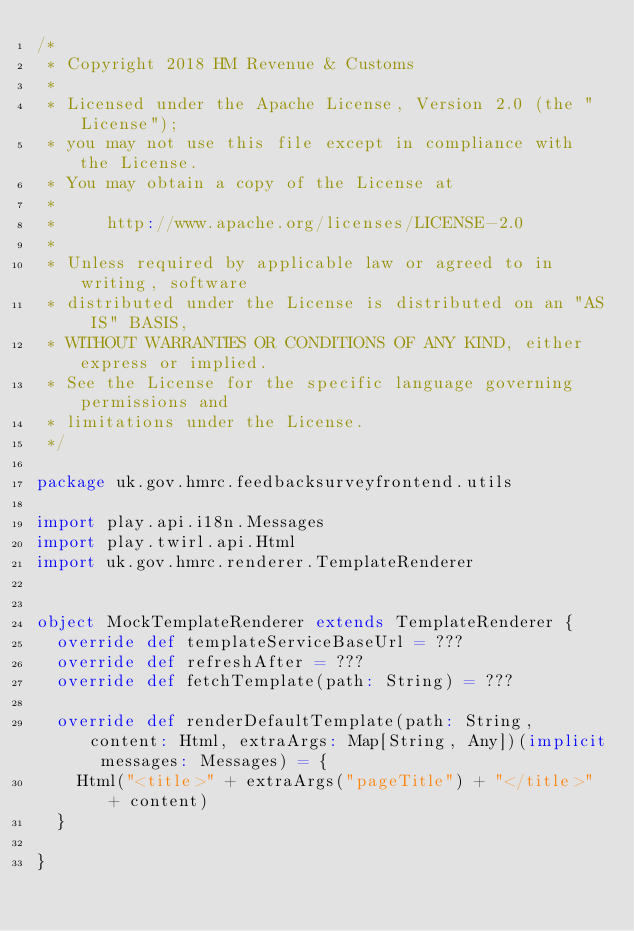<code> <loc_0><loc_0><loc_500><loc_500><_Scala_>/*
 * Copyright 2018 HM Revenue & Customs
 *
 * Licensed under the Apache License, Version 2.0 (the "License");
 * you may not use this file except in compliance with the License.
 * You may obtain a copy of the License at
 *
 *     http://www.apache.org/licenses/LICENSE-2.0
 *
 * Unless required by applicable law or agreed to in writing, software
 * distributed under the License is distributed on an "AS IS" BASIS,
 * WITHOUT WARRANTIES OR CONDITIONS OF ANY KIND, either express or implied.
 * See the License for the specific language governing permissions and
 * limitations under the License.
 */

package uk.gov.hmrc.feedbacksurveyfrontend.utils

import play.api.i18n.Messages
import play.twirl.api.Html
import uk.gov.hmrc.renderer.TemplateRenderer


object MockTemplateRenderer extends TemplateRenderer {
  override def templateServiceBaseUrl = ???
  override def refreshAfter = ???
  override def fetchTemplate(path: String) = ???

  override def renderDefaultTemplate(path: String, content: Html, extraArgs: Map[String, Any])(implicit messages: Messages) = {
    Html("<title>" + extraArgs("pageTitle") + "</title>" + content)
  }

}
</code> 